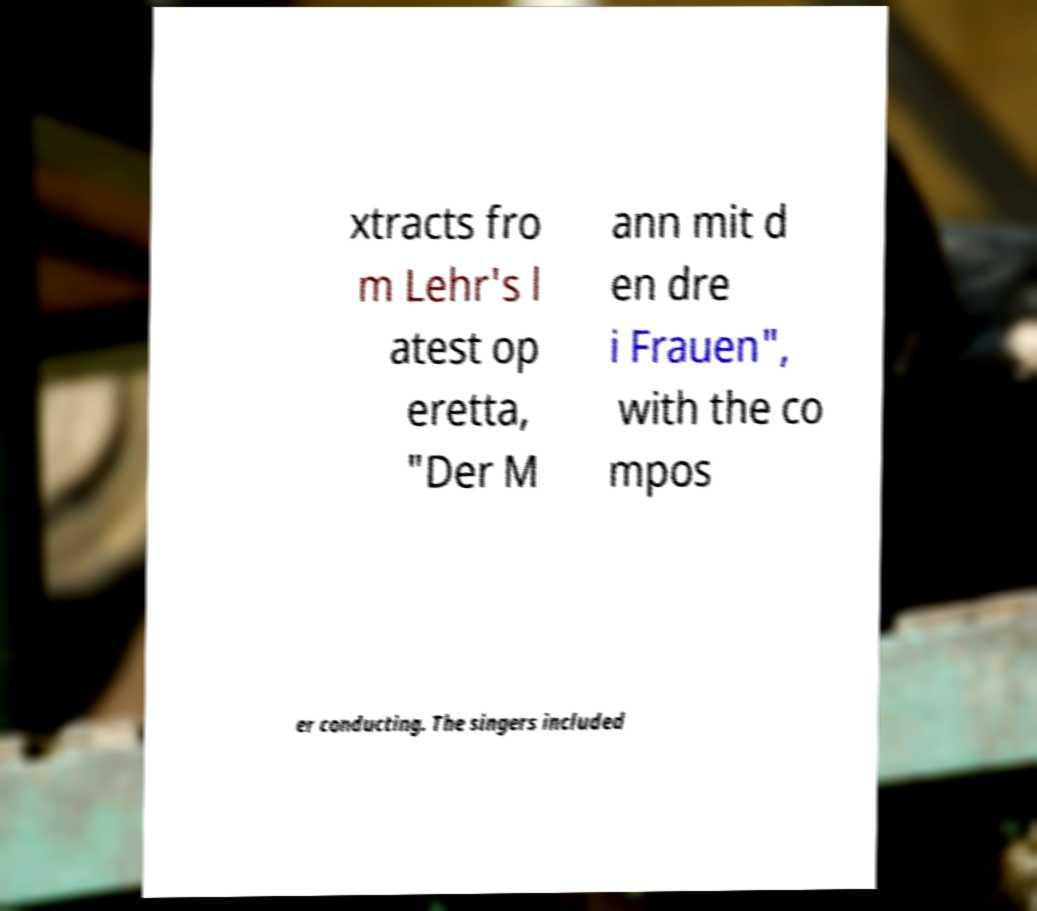Please identify and transcribe the text found in this image. xtracts fro m Lehr's l atest op eretta, "Der M ann mit d en dre i Frauen", with the co mpos er conducting. The singers included 